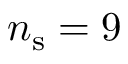<formula> <loc_0><loc_0><loc_500><loc_500>n _ { s } = 9</formula> 